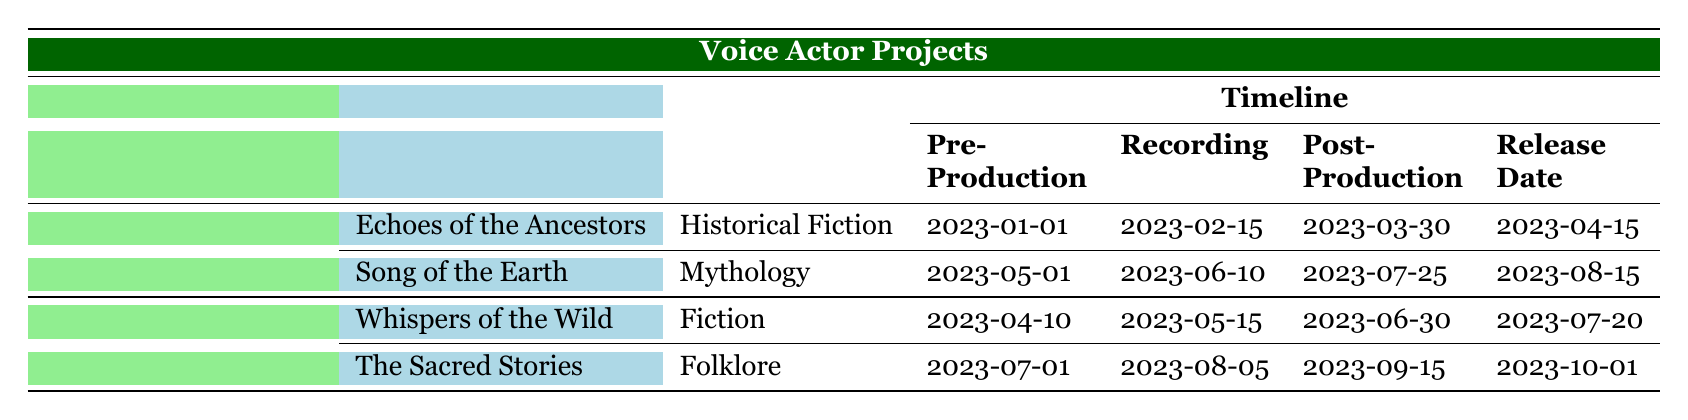What is the release date of "Echoes of the Ancestors"? The table under the column "Release Date" indicates the release date for "Echoes of the Ancestors" is 2023-04-15.
Answer: 2023-04-15 How many projects does Greenwood Publishing have listed? By counting the number of project titles listed under Greenwood Publishing in the table, there are 2 projects: "Echoes of the Ancestors" and "Song of the Earth."
Answer: 2 What story type is "The Sacred Stories"? The table states that "The Sacred Stories," listed under Skyline Audibles, has the story type categorized as "Folklore."
Answer: Folklore Which project has the earliest pre-production start date? Reviewing the pre-production dates, "Echoes of the Ancestors" starts on 2023-01-01, while others start later. Thus, it has the earliest date.
Answer: Echoes of the Ancestors Is the story type of "Song of the Earth" mythology? Referring to the table, "Song of the Earth" is indeed categorized as "Mythology." Therefore, the statement is true.
Answer: Yes What is the duration of the recording phase for "Whispers of the Wild"? The recording phase for "Whispers of the Wild" is recorded from 2023-05-15 to 2023-06-30. Calculating this duration gives 1 month and 15 days.
Answer: 1 month and 15 days Which client has the project with the latest release date? Looking at the release dates, "The Sacred Stories" is scheduled to release on 2023-10-01, which is the latest date compared to the others. Thus, Skyline Audibles has the project with the latest release date.
Answer: Skyline Audibles What is the total number of days from pre-production to release for "Song of the Earth"? "Song of the Earth" has a pre-production start date of 2023-05-01 and a release date of 2023-08-15. Calculating the total days between these two dates: 15 days in May (from the 1st to the 15th), 30 days in June, and 31 days in July, plus 15 days in August, gives a total of 90 days.
Answer: 90 days Which project has the longest post-production phase? "The Sacred Stories" has a post-production end date of 2023-09-15. For the other projects, calculating the post-production duration: "Echoes of the Ancestors" ends on 2023-03-30 and "Song of the Earth" on 2023-07-25. Therefore, comparing these durations shows "The Sacred Stories" has the longest post-production phase.
Answer: The Sacred Stories 